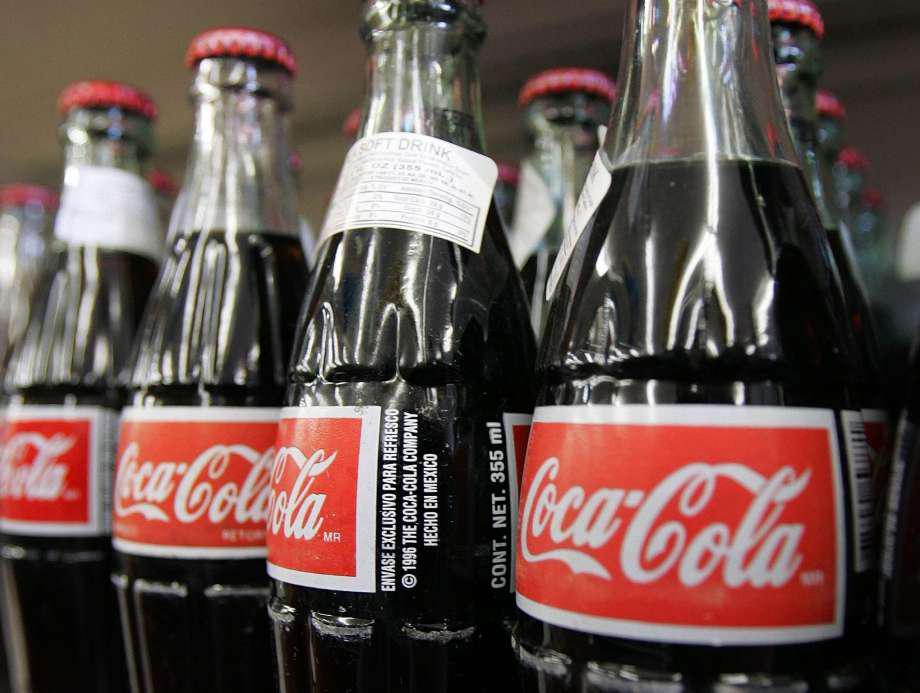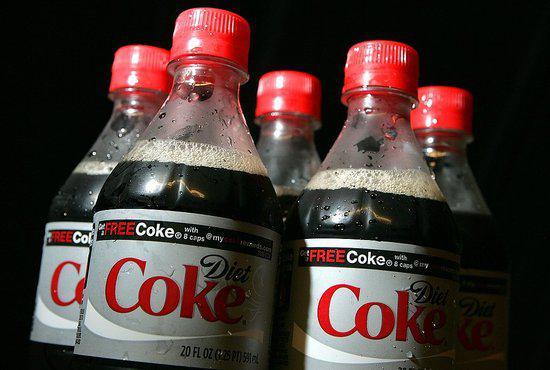The first image is the image on the left, the second image is the image on the right. Assess this claim about the two images: "The left image shows a row of at least three different glass soda bottles, and the right image includes multiple filled plastic soda bottles with different labels.". Correct or not? Answer yes or no. No. The first image is the image on the left, the second image is the image on the right. Assess this claim about the two images: "Rows of red-capped cola bottles with red and white labels are in one image, all but one with a second white rectangular label on the neck.". Correct or not? Answer yes or no. Yes. 